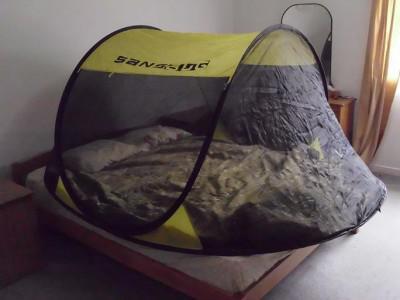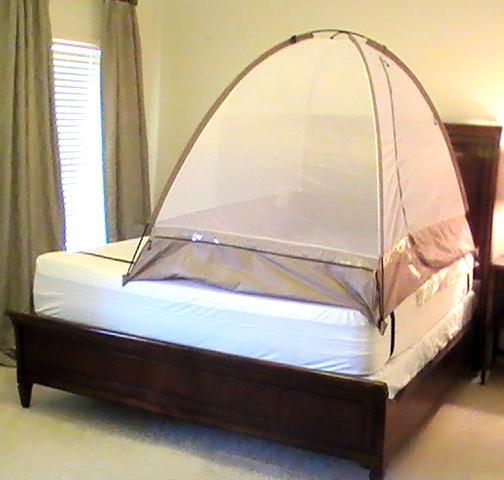The first image is the image on the left, the second image is the image on the right. Given the left and right images, does the statement "One image shows a dome canopy on top of a bed, and the other image features a sheer, blue trimmed canopy that ties like a curtain on at least one side of a bed." hold true? Answer yes or no. No. The first image is the image on the left, the second image is the image on the right. For the images displayed, is the sentence "The left and right image contains the same number of tented canopies." factually correct? Answer yes or no. Yes. 